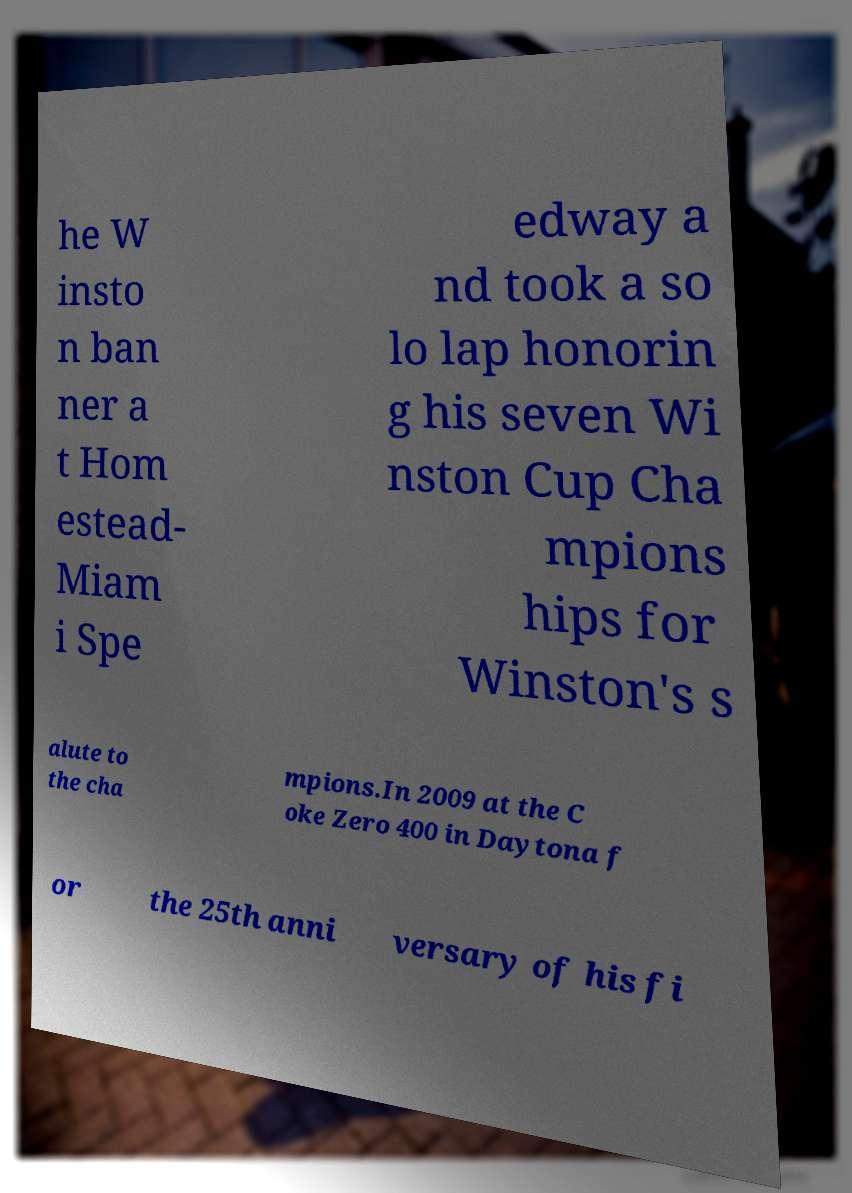Could you extract and type out the text from this image? he W insto n ban ner a t Hom estead- Miam i Spe edway a nd took a so lo lap honorin g his seven Wi nston Cup Cha mpions hips for Winston's s alute to the cha mpions.In 2009 at the C oke Zero 400 in Daytona f or the 25th anni versary of his fi 